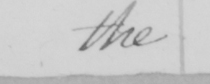What text is written in this handwritten line? the 